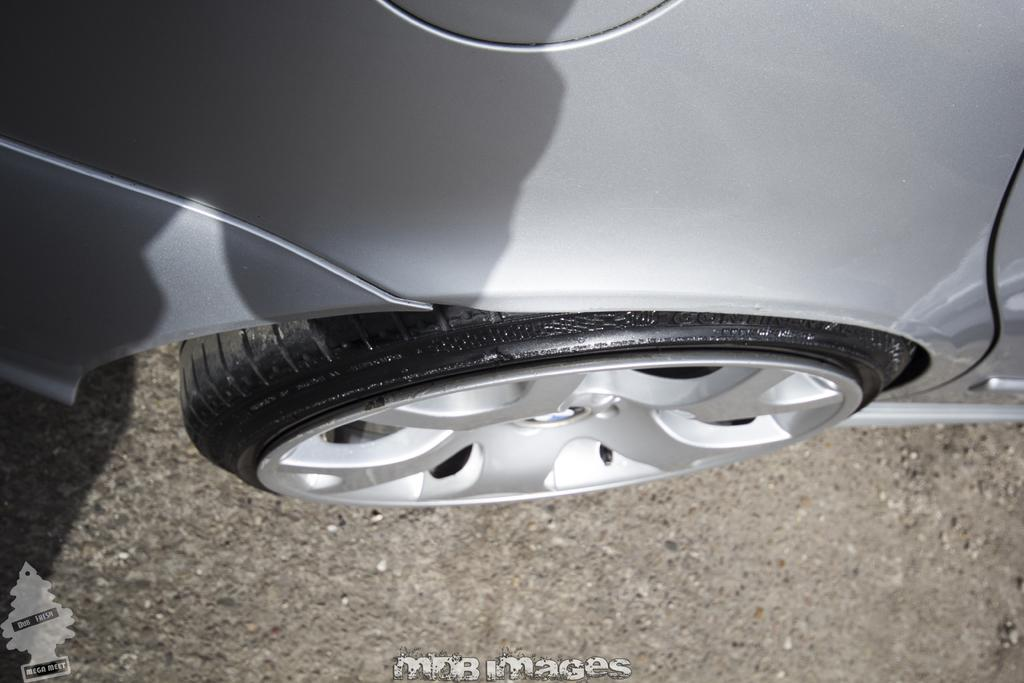What is the main subject of the image? There is a car in the center of the image. What is located at the bottom of the image? There is a road at the bottom of the image. Is there any text present in the image? Yes, there is some text at the bottom of the image. What type of juice is being served in the house depicted in the image? There is no house or juice present in the image; it only features a car and a road. What is the caption for the image? There is no caption provided with the image, as we are only given the facts about the car, road, and text. 